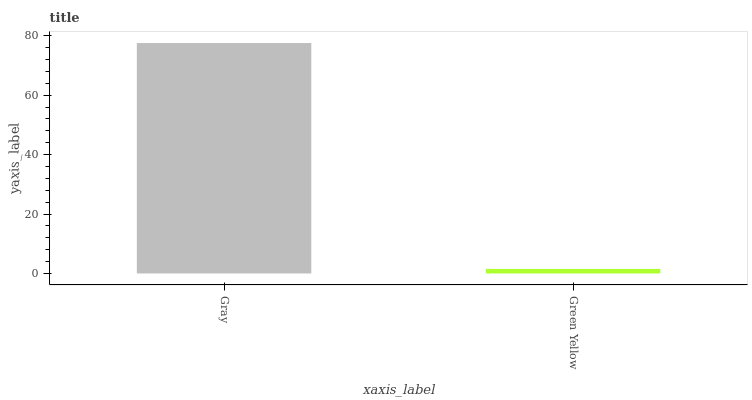Is Green Yellow the minimum?
Answer yes or no. Yes. Is Gray the maximum?
Answer yes or no. Yes. Is Green Yellow the maximum?
Answer yes or no. No. Is Gray greater than Green Yellow?
Answer yes or no. Yes. Is Green Yellow less than Gray?
Answer yes or no. Yes. Is Green Yellow greater than Gray?
Answer yes or no. No. Is Gray less than Green Yellow?
Answer yes or no. No. Is Gray the high median?
Answer yes or no. Yes. Is Green Yellow the low median?
Answer yes or no. Yes. Is Green Yellow the high median?
Answer yes or no. No. Is Gray the low median?
Answer yes or no. No. 